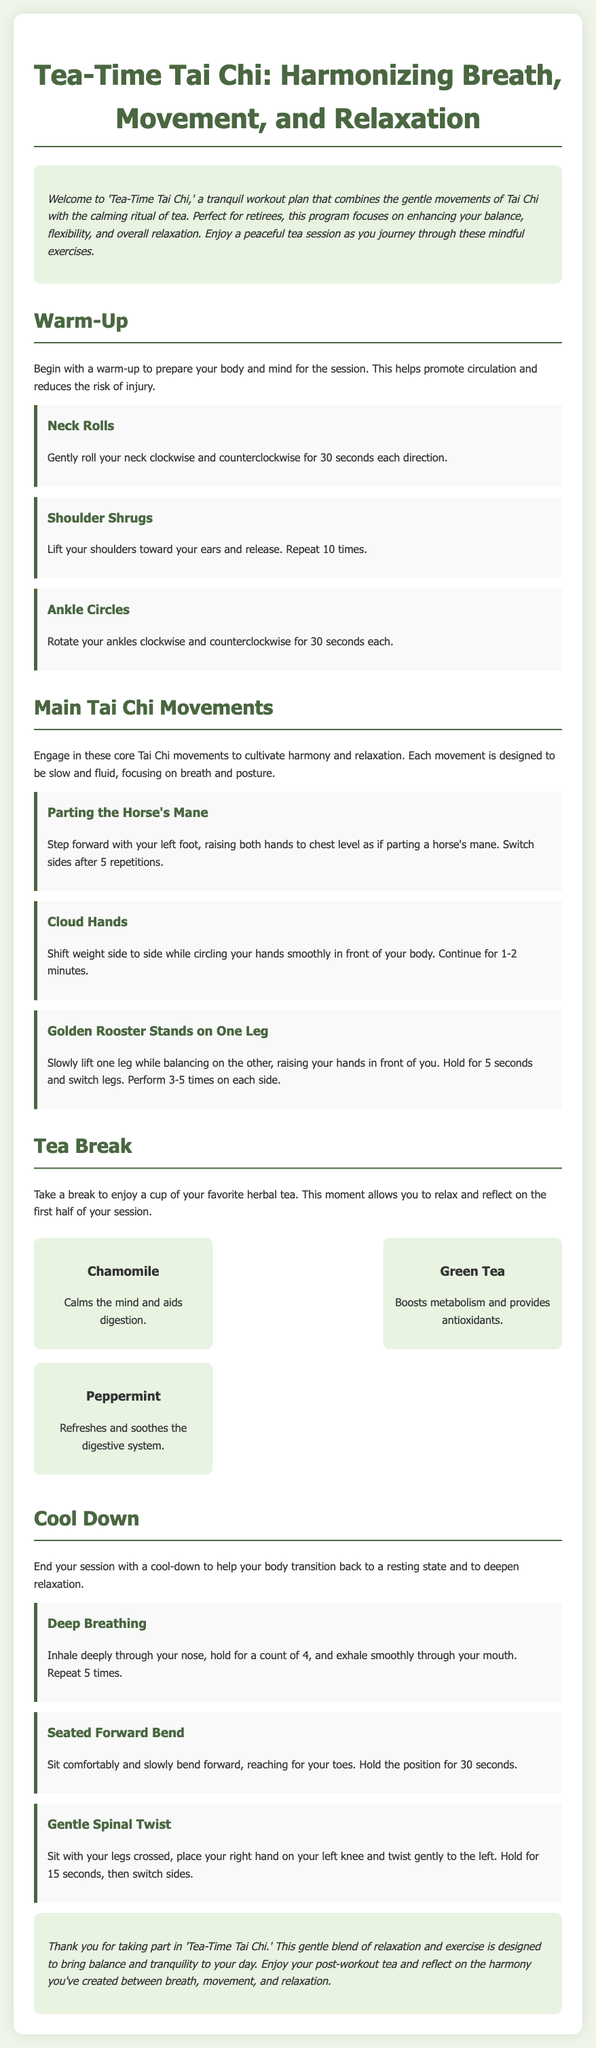What is the title of the workout plan? The title is explicitly stated in the document's header as "Tea-Time Tai Chi: Harmonizing Breath, Movement, and Relaxation."
Answer: Tea-Time Tai Chi: Harmonizing Breath, Movement, and Relaxation What is the first warm-up exercise listed? The first warm-up exercise mentioned in the document is "Neck Rolls."
Answer: Neck Rolls How long should you perform each neck roll? The document specifies to gently roll your neck for 30 seconds each direction.
Answer: 30 seconds What is suggested to do during the tea break? The document encourages enjoying a cup of your favorite herbal tea during the tea break.
Answer: Enjoy a cup of your favorite herbal tea Which tea is mentioned as being calming? The document lists "Chamomile" as a tea that calms the mind.
Answer: Chamomile What is the purpose of the cool-down? The document states that the cool-down helps the body transition back to a resting state and deepens relaxation.
Answer: Transition back to a resting state How many repetitions are suggested for the "Golden Rooster Stands on One Leg" exercise? It is suggested to perform this exercise 3-5 times on each side.
Answer: 3-5 times What type of movements does the workout focus on? The workout focuses on gentle movements of Tai Chi.
Answer: Gentle movements of Tai Chi 